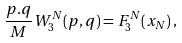Convert formula to latex. <formula><loc_0><loc_0><loc_500><loc_500>\frac { p . q } { M } W ^ { N } _ { 3 } ( p , q ) = F ^ { N } _ { 3 } ( x _ { N } ) \, ,</formula> 